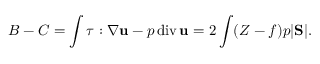<formula> <loc_0><loc_0><loc_500><loc_500>B - C = \int \tau \colon \nabla { u } - p \, d i v \, { u } = 2 \int ( Z - f ) p | S | .</formula> 